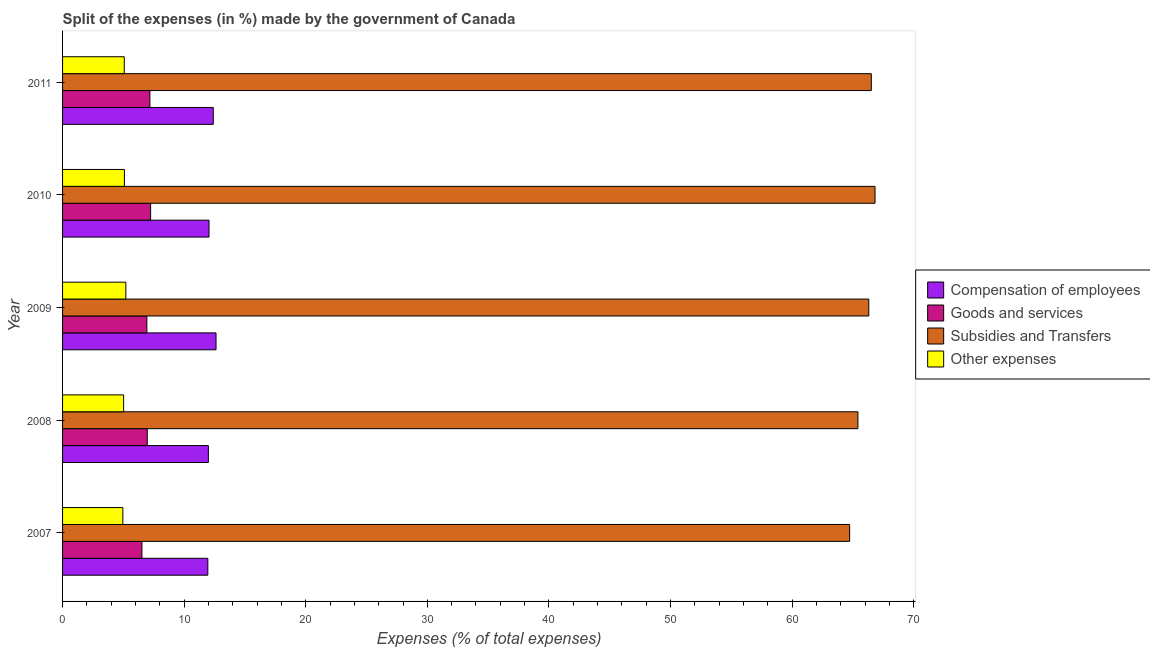Are the number of bars per tick equal to the number of legend labels?
Provide a short and direct response. Yes. How many bars are there on the 2nd tick from the top?
Keep it short and to the point. 4. What is the percentage of amount spent on subsidies in 2009?
Offer a terse response. 66.3. Across all years, what is the maximum percentage of amount spent on compensation of employees?
Your answer should be very brief. 12.62. Across all years, what is the minimum percentage of amount spent on other expenses?
Your response must be concise. 4.96. In which year was the percentage of amount spent on goods and services maximum?
Your answer should be very brief. 2010. What is the total percentage of amount spent on other expenses in the graph?
Provide a short and direct response. 25.35. What is the difference between the percentage of amount spent on other expenses in 2007 and that in 2008?
Offer a terse response. -0.06. What is the difference between the percentage of amount spent on goods and services in 2010 and the percentage of amount spent on other expenses in 2007?
Make the answer very short. 2.28. What is the average percentage of amount spent on goods and services per year?
Provide a short and direct response. 6.97. In the year 2009, what is the difference between the percentage of amount spent on goods and services and percentage of amount spent on compensation of employees?
Provide a succinct answer. -5.69. In how many years, is the percentage of amount spent on other expenses greater than 50 %?
Your response must be concise. 0. What is the ratio of the percentage of amount spent on subsidies in 2010 to that in 2011?
Give a very brief answer. 1. What is the difference between the highest and the second highest percentage of amount spent on subsidies?
Your answer should be very brief. 0.3. What is the difference between the highest and the lowest percentage of amount spent on subsidies?
Your response must be concise. 2.09. Is the sum of the percentage of amount spent on subsidies in 2008 and 2009 greater than the maximum percentage of amount spent on goods and services across all years?
Keep it short and to the point. Yes. What does the 2nd bar from the top in 2010 represents?
Keep it short and to the point. Subsidies and Transfers. What does the 3rd bar from the bottom in 2011 represents?
Your answer should be very brief. Subsidies and Transfers. How many bars are there?
Your answer should be compact. 20. How many years are there in the graph?
Ensure brevity in your answer.  5. What is the difference between two consecutive major ticks on the X-axis?
Ensure brevity in your answer.  10. What is the title of the graph?
Offer a terse response. Split of the expenses (in %) made by the government of Canada. Does "Natural Gas" appear as one of the legend labels in the graph?
Provide a short and direct response. No. What is the label or title of the X-axis?
Your answer should be compact. Expenses (% of total expenses). What is the label or title of the Y-axis?
Your answer should be very brief. Year. What is the Expenses (% of total expenses) of Compensation of employees in 2007?
Keep it short and to the point. 11.95. What is the Expenses (% of total expenses) in Goods and services in 2007?
Keep it short and to the point. 6.53. What is the Expenses (% of total expenses) of Subsidies and Transfers in 2007?
Provide a succinct answer. 64.73. What is the Expenses (% of total expenses) in Other expenses in 2007?
Offer a terse response. 4.96. What is the Expenses (% of total expenses) in Compensation of employees in 2008?
Keep it short and to the point. 11.99. What is the Expenses (% of total expenses) of Goods and services in 2008?
Provide a succinct answer. 6.97. What is the Expenses (% of total expenses) of Subsidies and Transfers in 2008?
Offer a very short reply. 65.41. What is the Expenses (% of total expenses) in Other expenses in 2008?
Your response must be concise. 5.02. What is the Expenses (% of total expenses) of Compensation of employees in 2009?
Provide a succinct answer. 12.62. What is the Expenses (% of total expenses) in Goods and services in 2009?
Give a very brief answer. 6.93. What is the Expenses (% of total expenses) in Subsidies and Transfers in 2009?
Give a very brief answer. 66.3. What is the Expenses (% of total expenses) in Other expenses in 2009?
Provide a short and direct response. 5.2. What is the Expenses (% of total expenses) in Compensation of employees in 2010?
Your answer should be compact. 12.04. What is the Expenses (% of total expenses) in Goods and services in 2010?
Your response must be concise. 7.24. What is the Expenses (% of total expenses) in Subsidies and Transfers in 2010?
Give a very brief answer. 66.82. What is the Expenses (% of total expenses) in Other expenses in 2010?
Provide a short and direct response. 5.09. What is the Expenses (% of total expenses) in Compensation of employees in 2011?
Provide a succinct answer. 12.39. What is the Expenses (% of total expenses) of Goods and services in 2011?
Provide a succinct answer. 7.18. What is the Expenses (% of total expenses) in Subsidies and Transfers in 2011?
Provide a succinct answer. 66.51. What is the Expenses (% of total expenses) in Other expenses in 2011?
Provide a succinct answer. 5.07. Across all years, what is the maximum Expenses (% of total expenses) in Compensation of employees?
Your response must be concise. 12.62. Across all years, what is the maximum Expenses (% of total expenses) in Goods and services?
Give a very brief answer. 7.24. Across all years, what is the maximum Expenses (% of total expenses) of Subsidies and Transfers?
Your response must be concise. 66.82. Across all years, what is the maximum Expenses (% of total expenses) in Other expenses?
Keep it short and to the point. 5.2. Across all years, what is the minimum Expenses (% of total expenses) of Compensation of employees?
Your answer should be compact. 11.95. Across all years, what is the minimum Expenses (% of total expenses) of Goods and services?
Ensure brevity in your answer.  6.53. Across all years, what is the minimum Expenses (% of total expenses) in Subsidies and Transfers?
Make the answer very short. 64.73. Across all years, what is the minimum Expenses (% of total expenses) in Other expenses?
Make the answer very short. 4.96. What is the total Expenses (% of total expenses) of Compensation of employees in the graph?
Ensure brevity in your answer.  61. What is the total Expenses (% of total expenses) of Goods and services in the graph?
Your answer should be very brief. 34.85. What is the total Expenses (% of total expenses) in Subsidies and Transfers in the graph?
Give a very brief answer. 329.78. What is the total Expenses (% of total expenses) in Other expenses in the graph?
Provide a succinct answer. 25.35. What is the difference between the Expenses (% of total expenses) of Compensation of employees in 2007 and that in 2008?
Provide a succinct answer. -0.05. What is the difference between the Expenses (% of total expenses) in Goods and services in 2007 and that in 2008?
Your answer should be compact. -0.44. What is the difference between the Expenses (% of total expenses) in Subsidies and Transfers in 2007 and that in 2008?
Give a very brief answer. -0.68. What is the difference between the Expenses (% of total expenses) of Other expenses in 2007 and that in 2008?
Your answer should be very brief. -0.06. What is the difference between the Expenses (% of total expenses) in Compensation of employees in 2007 and that in 2009?
Give a very brief answer. -0.67. What is the difference between the Expenses (% of total expenses) in Goods and services in 2007 and that in 2009?
Your answer should be compact. -0.4. What is the difference between the Expenses (% of total expenses) in Subsidies and Transfers in 2007 and that in 2009?
Your answer should be compact. -1.57. What is the difference between the Expenses (% of total expenses) of Other expenses in 2007 and that in 2009?
Give a very brief answer. -0.25. What is the difference between the Expenses (% of total expenses) in Compensation of employees in 2007 and that in 2010?
Your answer should be compact. -0.1. What is the difference between the Expenses (% of total expenses) of Goods and services in 2007 and that in 2010?
Offer a terse response. -0.71. What is the difference between the Expenses (% of total expenses) in Subsidies and Transfers in 2007 and that in 2010?
Your answer should be compact. -2.09. What is the difference between the Expenses (% of total expenses) of Other expenses in 2007 and that in 2010?
Offer a very short reply. -0.13. What is the difference between the Expenses (% of total expenses) of Compensation of employees in 2007 and that in 2011?
Keep it short and to the point. -0.45. What is the difference between the Expenses (% of total expenses) of Goods and services in 2007 and that in 2011?
Offer a very short reply. -0.65. What is the difference between the Expenses (% of total expenses) in Subsidies and Transfers in 2007 and that in 2011?
Offer a very short reply. -1.78. What is the difference between the Expenses (% of total expenses) in Other expenses in 2007 and that in 2011?
Provide a succinct answer. -0.12. What is the difference between the Expenses (% of total expenses) in Compensation of employees in 2008 and that in 2009?
Your answer should be compact. -0.63. What is the difference between the Expenses (% of total expenses) in Goods and services in 2008 and that in 2009?
Make the answer very short. 0.03. What is the difference between the Expenses (% of total expenses) of Subsidies and Transfers in 2008 and that in 2009?
Offer a very short reply. -0.89. What is the difference between the Expenses (% of total expenses) in Other expenses in 2008 and that in 2009?
Your answer should be compact. -0.18. What is the difference between the Expenses (% of total expenses) of Compensation of employees in 2008 and that in 2010?
Give a very brief answer. -0.05. What is the difference between the Expenses (% of total expenses) in Goods and services in 2008 and that in 2010?
Your response must be concise. -0.28. What is the difference between the Expenses (% of total expenses) of Subsidies and Transfers in 2008 and that in 2010?
Your response must be concise. -1.41. What is the difference between the Expenses (% of total expenses) of Other expenses in 2008 and that in 2010?
Your answer should be compact. -0.06. What is the difference between the Expenses (% of total expenses) in Compensation of employees in 2008 and that in 2011?
Give a very brief answer. -0.4. What is the difference between the Expenses (% of total expenses) in Goods and services in 2008 and that in 2011?
Ensure brevity in your answer.  -0.22. What is the difference between the Expenses (% of total expenses) of Subsidies and Transfers in 2008 and that in 2011?
Ensure brevity in your answer.  -1.1. What is the difference between the Expenses (% of total expenses) in Other expenses in 2008 and that in 2011?
Give a very brief answer. -0.05. What is the difference between the Expenses (% of total expenses) in Compensation of employees in 2009 and that in 2010?
Offer a terse response. 0.58. What is the difference between the Expenses (% of total expenses) of Goods and services in 2009 and that in 2010?
Provide a succinct answer. -0.31. What is the difference between the Expenses (% of total expenses) of Subsidies and Transfers in 2009 and that in 2010?
Ensure brevity in your answer.  -0.51. What is the difference between the Expenses (% of total expenses) in Other expenses in 2009 and that in 2010?
Your answer should be compact. 0.12. What is the difference between the Expenses (% of total expenses) of Compensation of employees in 2009 and that in 2011?
Offer a very short reply. 0.23. What is the difference between the Expenses (% of total expenses) in Goods and services in 2009 and that in 2011?
Your response must be concise. -0.25. What is the difference between the Expenses (% of total expenses) of Subsidies and Transfers in 2009 and that in 2011?
Provide a short and direct response. -0.21. What is the difference between the Expenses (% of total expenses) of Other expenses in 2009 and that in 2011?
Provide a short and direct response. 0.13. What is the difference between the Expenses (% of total expenses) of Compensation of employees in 2010 and that in 2011?
Provide a short and direct response. -0.35. What is the difference between the Expenses (% of total expenses) in Goods and services in 2010 and that in 2011?
Give a very brief answer. 0.06. What is the difference between the Expenses (% of total expenses) of Subsidies and Transfers in 2010 and that in 2011?
Keep it short and to the point. 0.31. What is the difference between the Expenses (% of total expenses) in Other expenses in 2010 and that in 2011?
Provide a short and direct response. 0.01. What is the difference between the Expenses (% of total expenses) in Compensation of employees in 2007 and the Expenses (% of total expenses) in Goods and services in 2008?
Your response must be concise. 4.98. What is the difference between the Expenses (% of total expenses) in Compensation of employees in 2007 and the Expenses (% of total expenses) in Subsidies and Transfers in 2008?
Provide a succinct answer. -53.47. What is the difference between the Expenses (% of total expenses) in Compensation of employees in 2007 and the Expenses (% of total expenses) in Other expenses in 2008?
Your response must be concise. 6.92. What is the difference between the Expenses (% of total expenses) of Goods and services in 2007 and the Expenses (% of total expenses) of Subsidies and Transfers in 2008?
Keep it short and to the point. -58.88. What is the difference between the Expenses (% of total expenses) of Goods and services in 2007 and the Expenses (% of total expenses) of Other expenses in 2008?
Your answer should be very brief. 1.5. What is the difference between the Expenses (% of total expenses) in Subsidies and Transfers in 2007 and the Expenses (% of total expenses) in Other expenses in 2008?
Provide a succinct answer. 59.71. What is the difference between the Expenses (% of total expenses) of Compensation of employees in 2007 and the Expenses (% of total expenses) of Goods and services in 2009?
Keep it short and to the point. 5.02. What is the difference between the Expenses (% of total expenses) in Compensation of employees in 2007 and the Expenses (% of total expenses) in Subsidies and Transfers in 2009?
Give a very brief answer. -54.36. What is the difference between the Expenses (% of total expenses) in Compensation of employees in 2007 and the Expenses (% of total expenses) in Other expenses in 2009?
Give a very brief answer. 6.74. What is the difference between the Expenses (% of total expenses) of Goods and services in 2007 and the Expenses (% of total expenses) of Subsidies and Transfers in 2009?
Provide a short and direct response. -59.78. What is the difference between the Expenses (% of total expenses) in Goods and services in 2007 and the Expenses (% of total expenses) in Other expenses in 2009?
Provide a succinct answer. 1.32. What is the difference between the Expenses (% of total expenses) in Subsidies and Transfers in 2007 and the Expenses (% of total expenses) in Other expenses in 2009?
Your answer should be very brief. 59.53. What is the difference between the Expenses (% of total expenses) of Compensation of employees in 2007 and the Expenses (% of total expenses) of Goods and services in 2010?
Your answer should be very brief. 4.7. What is the difference between the Expenses (% of total expenses) of Compensation of employees in 2007 and the Expenses (% of total expenses) of Subsidies and Transfers in 2010?
Your answer should be compact. -54.87. What is the difference between the Expenses (% of total expenses) in Compensation of employees in 2007 and the Expenses (% of total expenses) in Other expenses in 2010?
Keep it short and to the point. 6.86. What is the difference between the Expenses (% of total expenses) in Goods and services in 2007 and the Expenses (% of total expenses) in Subsidies and Transfers in 2010?
Make the answer very short. -60.29. What is the difference between the Expenses (% of total expenses) of Goods and services in 2007 and the Expenses (% of total expenses) of Other expenses in 2010?
Your answer should be compact. 1.44. What is the difference between the Expenses (% of total expenses) of Subsidies and Transfers in 2007 and the Expenses (% of total expenses) of Other expenses in 2010?
Your answer should be compact. 59.64. What is the difference between the Expenses (% of total expenses) in Compensation of employees in 2007 and the Expenses (% of total expenses) in Goods and services in 2011?
Give a very brief answer. 4.76. What is the difference between the Expenses (% of total expenses) of Compensation of employees in 2007 and the Expenses (% of total expenses) of Subsidies and Transfers in 2011?
Offer a very short reply. -54.57. What is the difference between the Expenses (% of total expenses) of Compensation of employees in 2007 and the Expenses (% of total expenses) of Other expenses in 2011?
Ensure brevity in your answer.  6.87. What is the difference between the Expenses (% of total expenses) in Goods and services in 2007 and the Expenses (% of total expenses) in Subsidies and Transfers in 2011?
Offer a terse response. -59.98. What is the difference between the Expenses (% of total expenses) in Goods and services in 2007 and the Expenses (% of total expenses) in Other expenses in 2011?
Offer a very short reply. 1.45. What is the difference between the Expenses (% of total expenses) in Subsidies and Transfers in 2007 and the Expenses (% of total expenses) in Other expenses in 2011?
Your answer should be compact. 59.66. What is the difference between the Expenses (% of total expenses) in Compensation of employees in 2008 and the Expenses (% of total expenses) in Goods and services in 2009?
Provide a succinct answer. 5.06. What is the difference between the Expenses (% of total expenses) in Compensation of employees in 2008 and the Expenses (% of total expenses) in Subsidies and Transfers in 2009?
Provide a short and direct response. -54.31. What is the difference between the Expenses (% of total expenses) in Compensation of employees in 2008 and the Expenses (% of total expenses) in Other expenses in 2009?
Provide a succinct answer. 6.79. What is the difference between the Expenses (% of total expenses) of Goods and services in 2008 and the Expenses (% of total expenses) of Subsidies and Transfers in 2009?
Offer a very short reply. -59.34. What is the difference between the Expenses (% of total expenses) of Goods and services in 2008 and the Expenses (% of total expenses) of Other expenses in 2009?
Keep it short and to the point. 1.76. What is the difference between the Expenses (% of total expenses) in Subsidies and Transfers in 2008 and the Expenses (% of total expenses) in Other expenses in 2009?
Offer a very short reply. 60.21. What is the difference between the Expenses (% of total expenses) in Compensation of employees in 2008 and the Expenses (% of total expenses) in Goods and services in 2010?
Provide a succinct answer. 4.75. What is the difference between the Expenses (% of total expenses) in Compensation of employees in 2008 and the Expenses (% of total expenses) in Subsidies and Transfers in 2010?
Your response must be concise. -54.83. What is the difference between the Expenses (% of total expenses) in Compensation of employees in 2008 and the Expenses (% of total expenses) in Other expenses in 2010?
Give a very brief answer. 6.9. What is the difference between the Expenses (% of total expenses) in Goods and services in 2008 and the Expenses (% of total expenses) in Subsidies and Transfers in 2010?
Ensure brevity in your answer.  -59.85. What is the difference between the Expenses (% of total expenses) of Goods and services in 2008 and the Expenses (% of total expenses) of Other expenses in 2010?
Your answer should be compact. 1.88. What is the difference between the Expenses (% of total expenses) in Subsidies and Transfers in 2008 and the Expenses (% of total expenses) in Other expenses in 2010?
Make the answer very short. 60.32. What is the difference between the Expenses (% of total expenses) of Compensation of employees in 2008 and the Expenses (% of total expenses) of Goods and services in 2011?
Give a very brief answer. 4.81. What is the difference between the Expenses (% of total expenses) of Compensation of employees in 2008 and the Expenses (% of total expenses) of Subsidies and Transfers in 2011?
Your answer should be compact. -54.52. What is the difference between the Expenses (% of total expenses) in Compensation of employees in 2008 and the Expenses (% of total expenses) in Other expenses in 2011?
Your answer should be compact. 6.92. What is the difference between the Expenses (% of total expenses) of Goods and services in 2008 and the Expenses (% of total expenses) of Subsidies and Transfers in 2011?
Offer a very short reply. -59.55. What is the difference between the Expenses (% of total expenses) of Goods and services in 2008 and the Expenses (% of total expenses) of Other expenses in 2011?
Provide a short and direct response. 1.89. What is the difference between the Expenses (% of total expenses) of Subsidies and Transfers in 2008 and the Expenses (% of total expenses) of Other expenses in 2011?
Ensure brevity in your answer.  60.34. What is the difference between the Expenses (% of total expenses) in Compensation of employees in 2009 and the Expenses (% of total expenses) in Goods and services in 2010?
Provide a succinct answer. 5.38. What is the difference between the Expenses (% of total expenses) in Compensation of employees in 2009 and the Expenses (% of total expenses) in Subsidies and Transfers in 2010?
Provide a short and direct response. -54.2. What is the difference between the Expenses (% of total expenses) in Compensation of employees in 2009 and the Expenses (% of total expenses) in Other expenses in 2010?
Give a very brief answer. 7.53. What is the difference between the Expenses (% of total expenses) of Goods and services in 2009 and the Expenses (% of total expenses) of Subsidies and Transfers in 2010?
Your response must be concise. -59.89. What is the difference between the Expenses (% of total expenses) of Goods and services in 2009 and the Expenses (% of total expenses) of Other expenses in 2010?
Ensure brevity in your answer.  1.84. What is the difference between the Expenses (% of total expenses) of Subsidies and Transfers in 2009 and the Expenses (% of total expenses) of Other expenses in 2010?
Keep it short and to the point. 61.22. What is the difference between the Expenses (% of total expenses) in Compensation of employees in 2009 and the Expenses (% of total expenses) in Goods and services in 2011?
Give a very brief answer. 5.44. What is the difference between the Expenses (% of total expenses) of Compensation of employees in 2009 and the Expenses (% of total expenses) of Subsidies and Transfers in 2011?
Keep it short and to the point. -53.89. What is the difference between the Expenses (% of total expenses) of Compensation of employees in 2009 and the Expenses (% of total expenses) of Other expenses in 2011?
Your response must be concise. 7.55. What is the difference between the Expenses (% of total expenses) in Goods and services in 2009 and the Expenses (% of total expenses) in Subsidies and Transfers in 2011?
Offer a terse response. -59.58. What is the difference between the Expenses (% of total expenses) in Goods and services in 2009 and the Expenses (% of total expenses) in Other expenses in 2011?
Provide a succinct answer. 1.86. What is the difference between the Expenses (% of total expenses) in Subsidies and Transfers in 2009 and the Expenses (% of total expenses) in Other expenses in 2011?
Your answer should be very brief. 61.23. What is the difference between the Expenses (% of total expenses) in Compensation of employees in 2010 and the Expenses (% of total expenses) in Goods and services in 2011?
Keep it short and to the point. 4.86. What is the difference between the Expenses (% of total expenses) in Compensation of employees in 2010 and the Expenses (% of total expenses) in Subsidies and Transfers in 2011?
Provide a short and direct response. -54.47. What is the difference between the Expenses (% of total expenses) in Compensation of employees in 2010 and the Expenses (% of total expenses) in Other expenses in 2011?
Your response must be concise. 6.97. What is the difference between the Expenses (% of total expenses) in Goods and services in 2010 and the Expenses (% of total expenses) in Subsidies and Transfers in 2011?
Provide a succinct answer. -59.27. What is the difference between the Expenses (% of total expenses) in Goods and services in 2010 and the Expenses (% of total expenses) in Other expenses in 2011?
Give a very brief answer. 2.17. What is the difference between the Expenses (% of total expenses) in Subsidies and Transfers in 2010 and the Expenses (% of total expenses) in Other expenses in 2011?
Your answer should be very brief. 61.74. What is the average Expenses (% of total expenses) of Compensation of employees per year?
Keep it short and to the point. 12.2. What is the average Expenses (% of total expenses) of Goods and services per year?
Give a very brief answer. 6.97. What is the average Expenses (% of total expenses) in Subsidies and Transfers per year?
Offer a very short reply. 65.96. What is the average Expenses (% of total expenses) of Other expenses per year?
Your answer should be very brief. 5.07. In the year 2007, what is the difference between the Expenses (% of total expenses) in Compensation of employees and Expenses (% of total expenses) in Goods and services?
Make the answer very short. 5.42. In the year 2007, what is the difference between the Expenses (% of total expenses) in Compensation of employees and Expenses (% of total expenses) in Subsidies and Transfers?
Make the answer very short. -52.78. In the year 2007, what is the difference between the Expenses (% of total expenses) in Compensation of employees and Expenses (% of total expenses) in Other expenses?
Your response must be concise. 6.99. In the year 2007, what is the difference between the Expenses (% of total expenses) in Goods and services and Expenses (% of total expenses) in Subsidies and Transfers?
Provide a short and direct response. -58.2. In the year 2007, what is the difference between the Expenses (% of total expenses) of Goods and services and Expenses (% of total expenses) of Other expenses?
Make the answer very short. 1.57. In the year 2007, what is the difference between the Expenses (% of total expenses) in Subsidies and Transfers and Expenses (% of total expenses) in Other expenses?
Make the answer very short. 59.77. In the year 2008, what is the difference between the Expenses (% of total expenses) of Compensation of employees and Expenses (% of total expenses) of Goods and services?
Offer a very short reply. 5.03. In the year 2008, what is the difference between the Expenses (% of total expenses) of Compensation of employees and Expenses (% of total expenses) of Subsidies and Transfers?
Offer a very short reply. -53.42. In the year 2008, what is the difference between the Expenses (% of total expenses) in Compensation of employees and Expenses (% of total expenses) in Other expenses?
Offer a very short reply. 6.97. In the year 2008, what is the difference between the Expenses (% of total expenses) in Goods and services and Expenses (% of total expenses) in Subsidies and Transfers?
Your response must be concise. -58.45. In the year 2008, what is the difference between the Expenses (% of total expenses) in Goods and services and Expenses (% of total expenses) in Other expenses?
Your answer should be compact. 1.94. In the year 2008, what is the difference between the Expenses (% of total expenses) of Subsidies and Transfers and Expenses (% of total expenses) of Other expenses?
Provide a short and direct response. 60.39. In the year 2009, what is the difference between the Expenses (% of total expenses) in Compensation of employees and Expenses (% of total expenses) in Goods and services?
Ensure brevity in your answer.  5.69. In the year 2009, what is the difference between the Expenses (% of total expenses) in Compensation of employees and Expenses (% of total expenses) in Subsidies and Transfers?
Your answer should be very brief. -53.68. In the year 2009, what is the difference between the Expenses (% of total expenses) in Compensation of employees and Expenses (% of total expenses) in Other expenses?
Your response must be concise. 7.42. In the year 2009, what is the difference between the Expenses (% of total expenses) of Goods and services and Expenses (% of total expenses) of Subsidies and Transfers?
Ensure brevity in your answer.  -59.37. In the year 2009, what is the difference between the Expenses (% of total expenses) in Goods and services and Expenses (% of total expenses) in Other expenses?
Provide a short and direct response. 1.73. In the year 2009, what is the difference between the Expenses (% of total expenses) in Subsidies and Transfers and Expenses (% of total expenses) in Other expenses?
Keep it short and to the point. 61.1. In the year 2010, what is the difference between the Expenses (% of total expenses) of Compensation of employees and Expenses (% of total expenses) of Goods and services?
Give a very brief answer. 4.8. In the year 2010, what is the difference between the Expenses (% of total expenses) of Compensation of employees and Expenses (% of total expenses) of Subsidies and Transfers?
Offer a very short reply. -54.77. In the year 2010, what is the difference between the Expenses (% of total expenses) in Compensation of employees and Expenses (% of total expenses) in Other expenses?
Provide a short and direct response. 6.96. In the year 2010, what is the difference between the Expenses (% of total expenses) of Goods and services and Expenses (% of total expenses) of Subsidies and Transfers?
Provide a succinct answer. -59.58. In the year 2010, what is the difference between the Expenses (% of total expenses) in Goods and services and Expenses (% of total expenses) in Other expenses?
Provide a succinct answer. 2.15. In the year 2010, what is the difference between the Expenses (% of total expenses) of Subsidies and Transfers and Expenses (% of total expenses) of Other expenses?
Give a very brief answer. 61.73. In the year 2011, what is the difference between the Expenses (% of total expenses) in Compensation of employees and Expenses (% of total expenses) in Goods and services?
Provide a short and direct response. 5.21. In the year 2011, what is the difference between the Expenses (% of total expenses) in Compensation of employees and Expenses (% of total expenses) in Subsidies and Transfers?
Provide a succinct answer. -54.12. In the year 2011, what is the difference between the Expenses (% of total expenses) in Compensation of employees and Expenses (% of total expenses) in Other expenses?
Your answer should be compact. 7.32. In the year 2011, what is the difference between the Expenses (% of total expenses) in Goods and services and Expenses (% of total expenses) in Subsidies and Transfers?
Your answer should be compact. -59.33. In the year 2011, what is the difference between the Expenses (% of total expenses) of Goods and services and Expenses (% of total expenses) of Other expenses?
Your answer should be compact. 2.11. In the year 2011, what is the difference between the Expenses (% of total expenses) of Subsidies and Transfers and Expenses (% of total expenses) of Other expenses?
Provide a succinct answer. 61.44. What is the ratio of the Expenses (% of total expenses) of Goods and services in 2007 to that in 2008?
Ensure brevity in your answer.  0.94. What is the ratio of the Expenses (% of total expenses) of Other expenses in 2007 to that in 2008?
Provide a succinct answer. 0.99. What is the ratio of the Expenses (% of total expenses) in Compensation of employees in 2007 to that in 2009?
Your response must be concise. 0.95. What is the ratio of the Expenses (% of total expenses) in Goods and services in 2007 to that in 2009?
Offer a terse response. 0.94. What is the ratio of the Expenses (% of total expenses) of Subsidies and Transfers in 2007 to that in 2009?
Ensure brevity in your answer.  0.98. What is the ratio of the Expenses (% of total expenses) in Other expenses in 2007 to that in 2009?
Offer a terse response. 0.95. What is the ratio of the Expenses (% of total expenses) in Compensation of employees in 2007 to that in 2010?
Offer a terse response. 0.99. What is the ratio of the Expenses (% of total expenses) in Goods and services in 2007 to that in 2010?
Provide a succinct answer. 0.9. What is the ratio of the Expenses (% of total expenses) of Subsidies and Transfers in 2007 to that in 2010?
Your response must be concise. 0.97. What is the ratio of the Expenses (% of total expenses) in Other expenses in 2007 to that in 2010?
Offer a very short reply. 0.97. What is the ratio of the Expenses (% of total expenses) of Compensation of employees in 2007 to that in 2011?
Offer a very short reply. 0.96. What is the ratio of the Expenses (% of total expenses) in Goods and services in 2007 to that in 2011?
Keep it short and to the point. 0.91. What is the ratio of the Expenses (% of total expenses) of Subsidies and Transfers in 2007 to that in 2011?
Offer a very short reply. 0.97. What is the ratio of the Expenses (% of total expenses) in Other expenses in 2007 to that in 2011?
Offer a very short reply. 0.98. What is the ratio of the Expenses (% of total expenses) of Compensation of employees in 2008 to that in 2009?
Provide a short and direct response. 0.95. What is the ratio of the Expenses (% of total expenses) in Subsidies and Transfers in 2008 to that in 2009?
Your response must be concise. 0.99. What is the ratio of the Expenses (% of total expenses) in Other expenses in 2008 to that in 2009?
Make the answer very short. 0.97. What is the ratio of the Expenses (% of total expenses) of Goods and services in 2008 to that in 2010?
Your answer should be compact. 0.96. What is the ratio of the Expenses (% of total expenses) in Subsidies and Transfers in 2008 to that in 2010?
Offer a terse response. 0.98. What is the ratio of the Expenses (% of total expenses) in Other expenses in 2008 to that in 2010?
Your answer should be compact. 0.99. What is the ratio of the Expenses (% of total expenses) in Compensation of employees in 2008 to that in 2011?
Your answer should be compact. 0.97. What is the ratio of the Expenses (% of total expenses) of Goods and services in 2008 to that in 2011?
Provide a succinct answer. 0.97. What is the ratio of the Expenses (% of total expenses) in Subsidies and Transfers in 2008 to that in 2011?
Give a very brief answer. 0.98. What is the ratio of the Expenses (% of total expenses) of Other expenses in 2008 to that in 2011?
Give a very brief answer. 0.99. What is the ratio of the Expenses (% of total expenses) in Compensation of employees in 2009 to that in 2010?
Offer a terse response. 1.05. What is the ratio of the Expenses (% of total expenses) in Subsidies and Transfers in 2009 to that in 2010?
Offer a terse response. 0.99. What is the ratio of the Expenses (% of total expenses) in Other expenses in 2009 to that in 2010?
Provide a short and direct response. 1.02. What is the ratio of the Expenses (% of total expenses) of Compensation of employees in 2009 to that in 2011?
Offer a very short reply. 1.02. What is the ratio of the Expenses (% of total expenses) of Other expenses in 2009 to that in 2011?
Provide a succinct answer. 1.03. What is the ratio of the Expenses (% of total expenses) in Compensation of employees in 2010 to that in 2011?
Offer a terse response. 0.97. What is the ratio of the Expenses (% of total expenses) of Goods and services in 2010 to that in 2011?
Ensure brevity in your answer.  1.01. What is the ratio of the Expenses (% of total expenses) in Subsidies and Transfers in 2010 to that in 2011?
Ensure brevity in your answer.  1. What is the difference between the highest and the second highest Expenses (% of total expenses) in Compensation of employees?
Keep it short and to the point. 0.23. What is the difference between the highest and the second highest Expenses (% of total expenses) of Goods and services?
Provide a succinct answer. 0.06. What is the difference between the highest and the second highest Expenses (% of total expenses) in Subsidies and Transfers?
Provide a short and direct response. 0.31. What is the difference between the highest and the second highest Expenses (% of total expenses) in Other expenses?
Give a very brief answer. 0.12. What is the difference between the highest and the lowest Expenses (% of total expenses) of Compensation of employees?
Your answer should be compact. 0.67. What is the difference between the highest and the lowest Expenses (% of total expenses) in Goods and services?
Provide a succinct answer. 0.71. What is the difference between the highest and the lowest Expenses (% of total expenses) in Subsidies and Transfers?
Ensure brevity in your answer.  2.09. What is the difference between the highest and the lowest Expenses (% of total expenses) in Other expenses?
Offer a terse response. 0.25. 